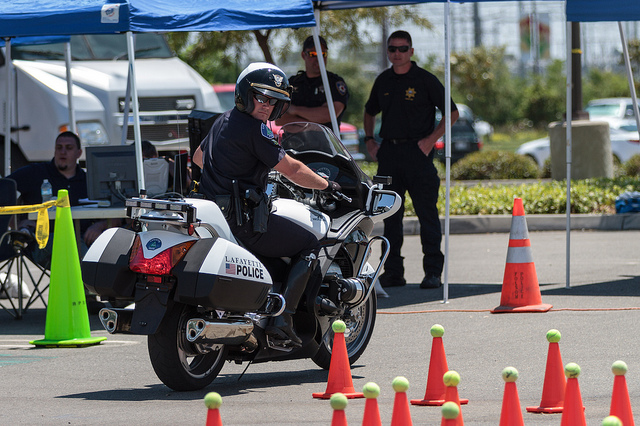<image>What is the event? It is ambiguous what the event is. It could be a parade, police training, game, fair, motorcycle cop event, fundraiser or training. What is the event? I don't know what the event is. It can be a parade, police training, game, fair, motorcycle cop event, fundraiser, or training. 